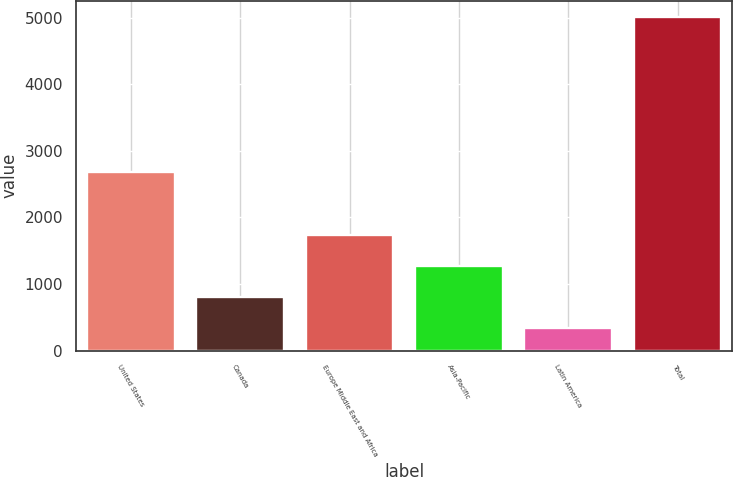Convert chart. <chart><loc_0><loc_0><loc_500><loc_500><bar_chart><fcel>United States<fcel>Canada<fcel>Europe Middle East and Africa<fcel>Asia-Pacific<fcel>Latin America<fcel>Total<nl><fcel>2687<fcel>799.91<fcel>1734.13<fcel>1267.02<fcel>332.8<fcel>5003.9<nl></chart> 